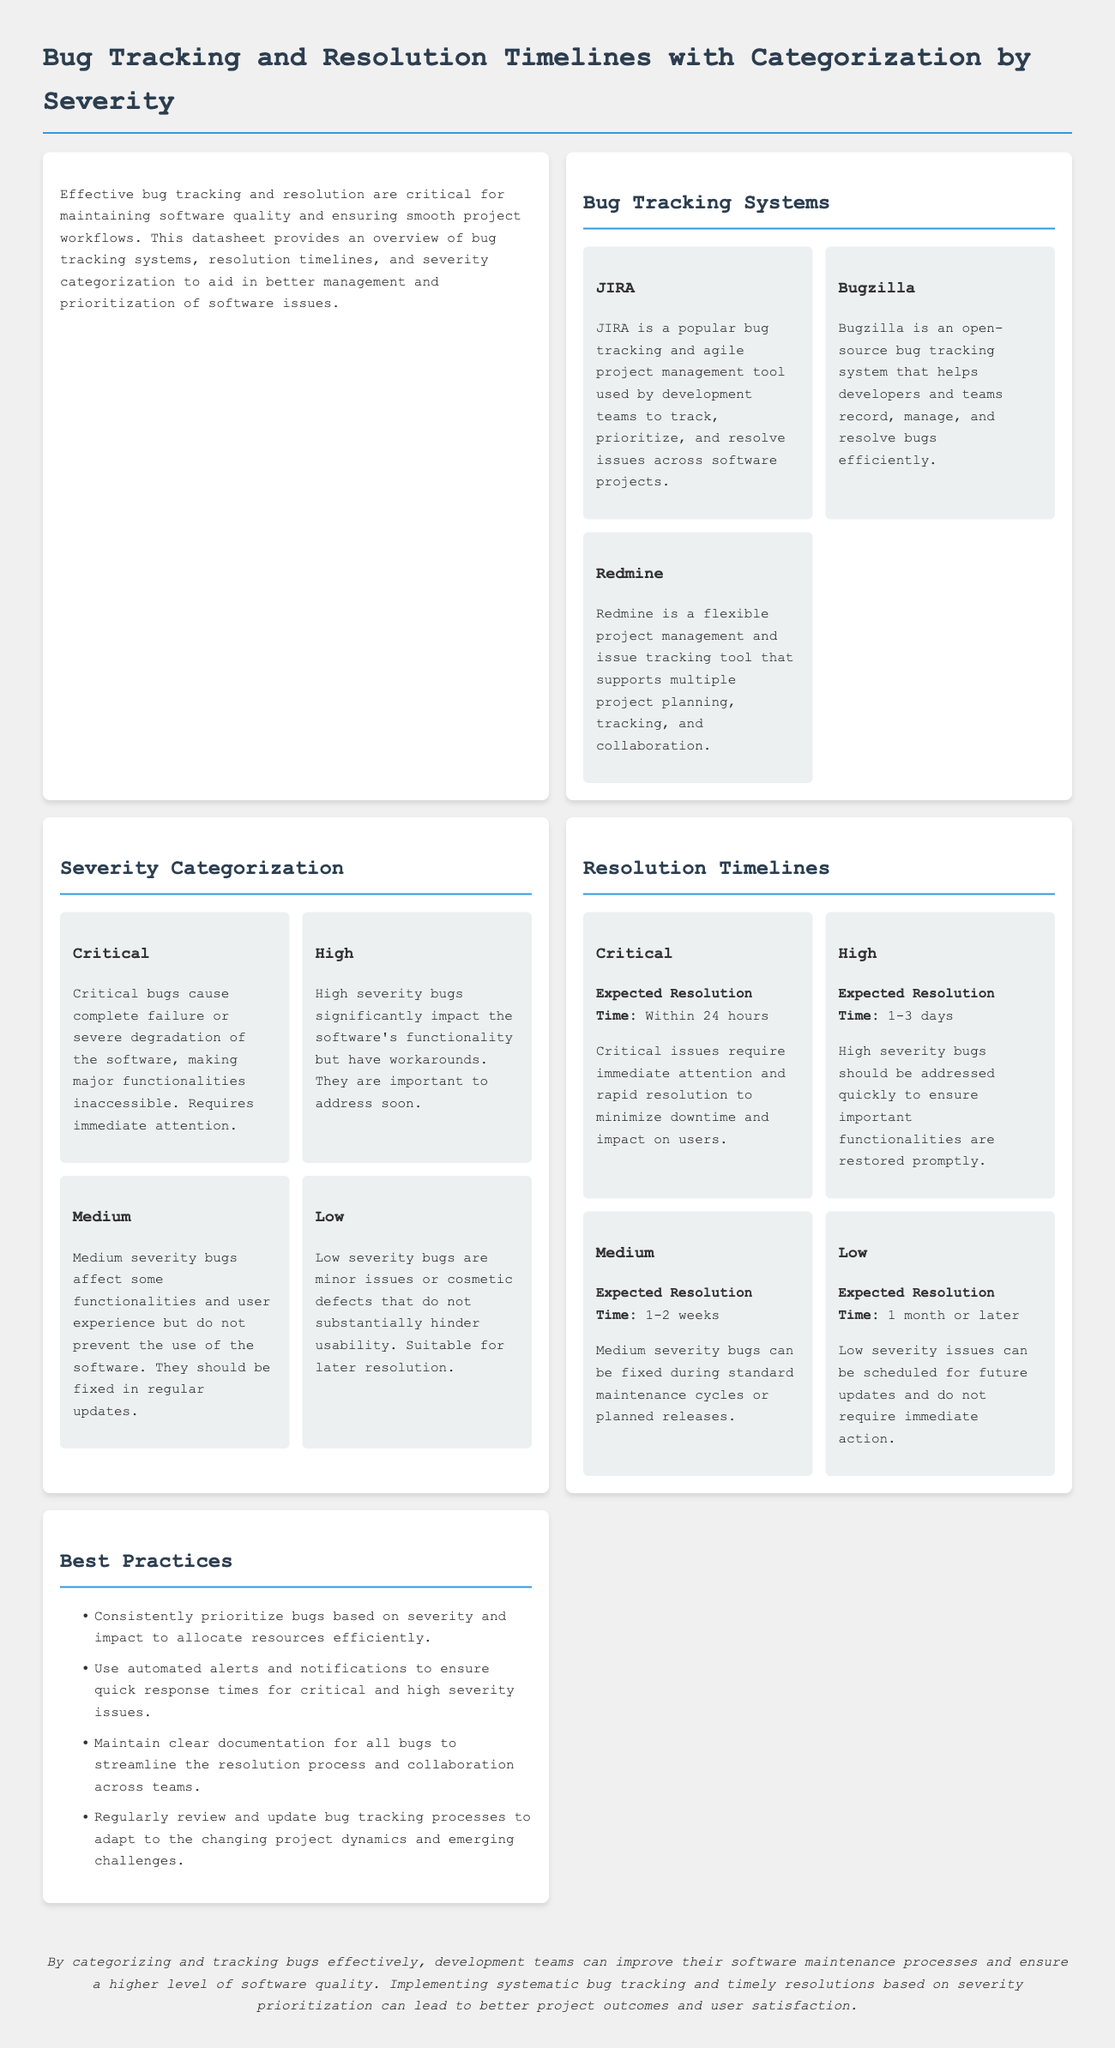What is the title of the datasheet? The title of the datasheet is found in the header section of the document.
Answer: Bug Tracking and Resolution Timelines with Categorization by Severity What tool is used for bug tracking and agile project management? The document lists various tools under the bug tracking systems section.
Answer: JIRA How many severity categories are defined in the datasheet? The severity categorization section outlines multiple levels of severity.
Answer: Four What is the expected resolution time for Critical bugs? The resolution timelines section states specific timings related to bug severity.
Answer: Within 24 hours Which system is described as an open-source bug tracking system? The document specifies the type of systems under the bug tracking systems section.
Answer: Bugzilla What severity categorization includes issues that are minor and suitable for later resolution? The severity categorization section explains the different types of severity of bugs.
Answer: Low How long should Medium severity bugs take to resolve? The resolution timelines section provides specific timeframes for bug resolution based on severity.
Answer: 1-2 weeks What is one best practice for bug tracking mentioned in the datasheet? The best practices section lists several recommendations for effective bug tracking.
Answer: Prioritize bugs based on severity and impact What color is used for the header text in the document? The style section describes the appearance of different text elements in the document.
Answer: #2c3e50 